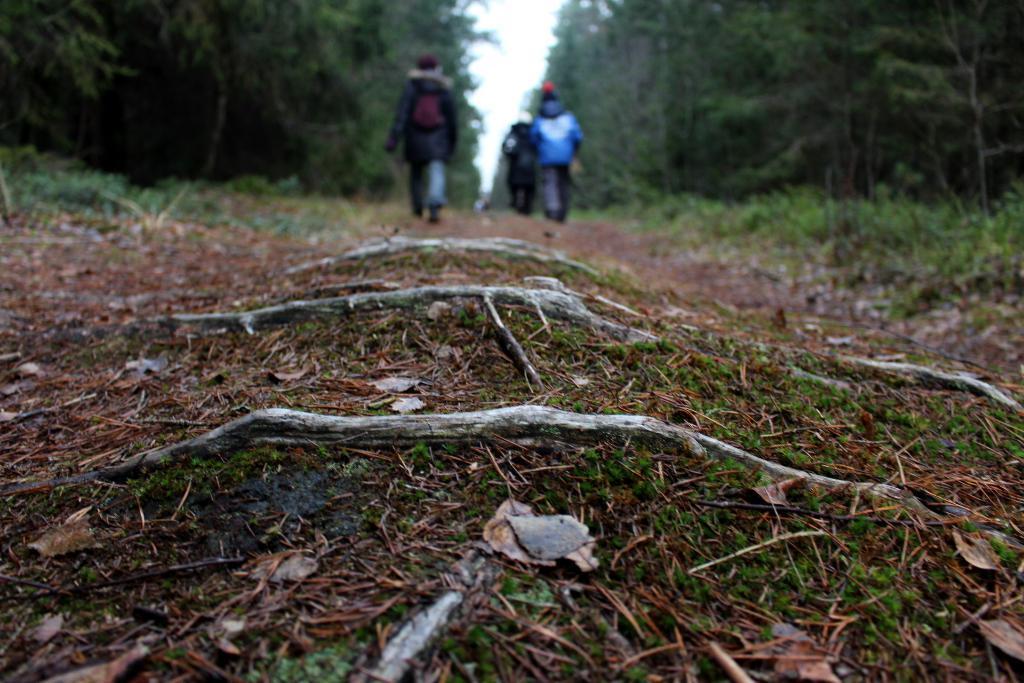In one or two sentences, can you explain what this image depicts? In this image we can see walkway and there are some persons walking through the walkway, there are some trees on left and right side of the image and top of the image there is clear sky. 